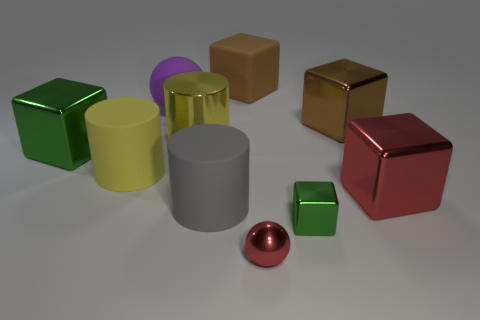Does the green object that is right of the big yellow metal thing have the same shape as the big brown matte thing left of the red metallic cube?
Your answer should be compact. Yes. There is a green block that is in front of the large green metal block; what is it made of?
Provide a short and direct response. Metal. What number of things are tiny green metallic blocks right of the small red metal ball or big shiny things?
Your response must be concise. 5. Is the number of large red metallic blocks that are behind the yellow shiny thing the same as the number of brown metal cylinders?
Ensure brevity in your answer.  Yes. Is the brown matte cube the same size as the purple rubber object?
Make the answer very short. Yes. There is a shiny cylinder that is the same size as the purple rubber ball; what color is it?
Provide a short and direct response. Yellow. There is a gray object; is its size the same as the brown metallic object behind the small green block?
Provide a short and direct response. Yes. What number of metal objects are the same color as the shiny ball?
Keep it short and to the point. 1. How many things are either green rubber cylinders or big rubber objects to the left of the rubber sphere?
Provide a succinct answer. 1. Is the size of the ball that is on the left side of the big shiny cylinder the same as the green block that is right of the red shiny ball?
Your answer should be compact. No. 